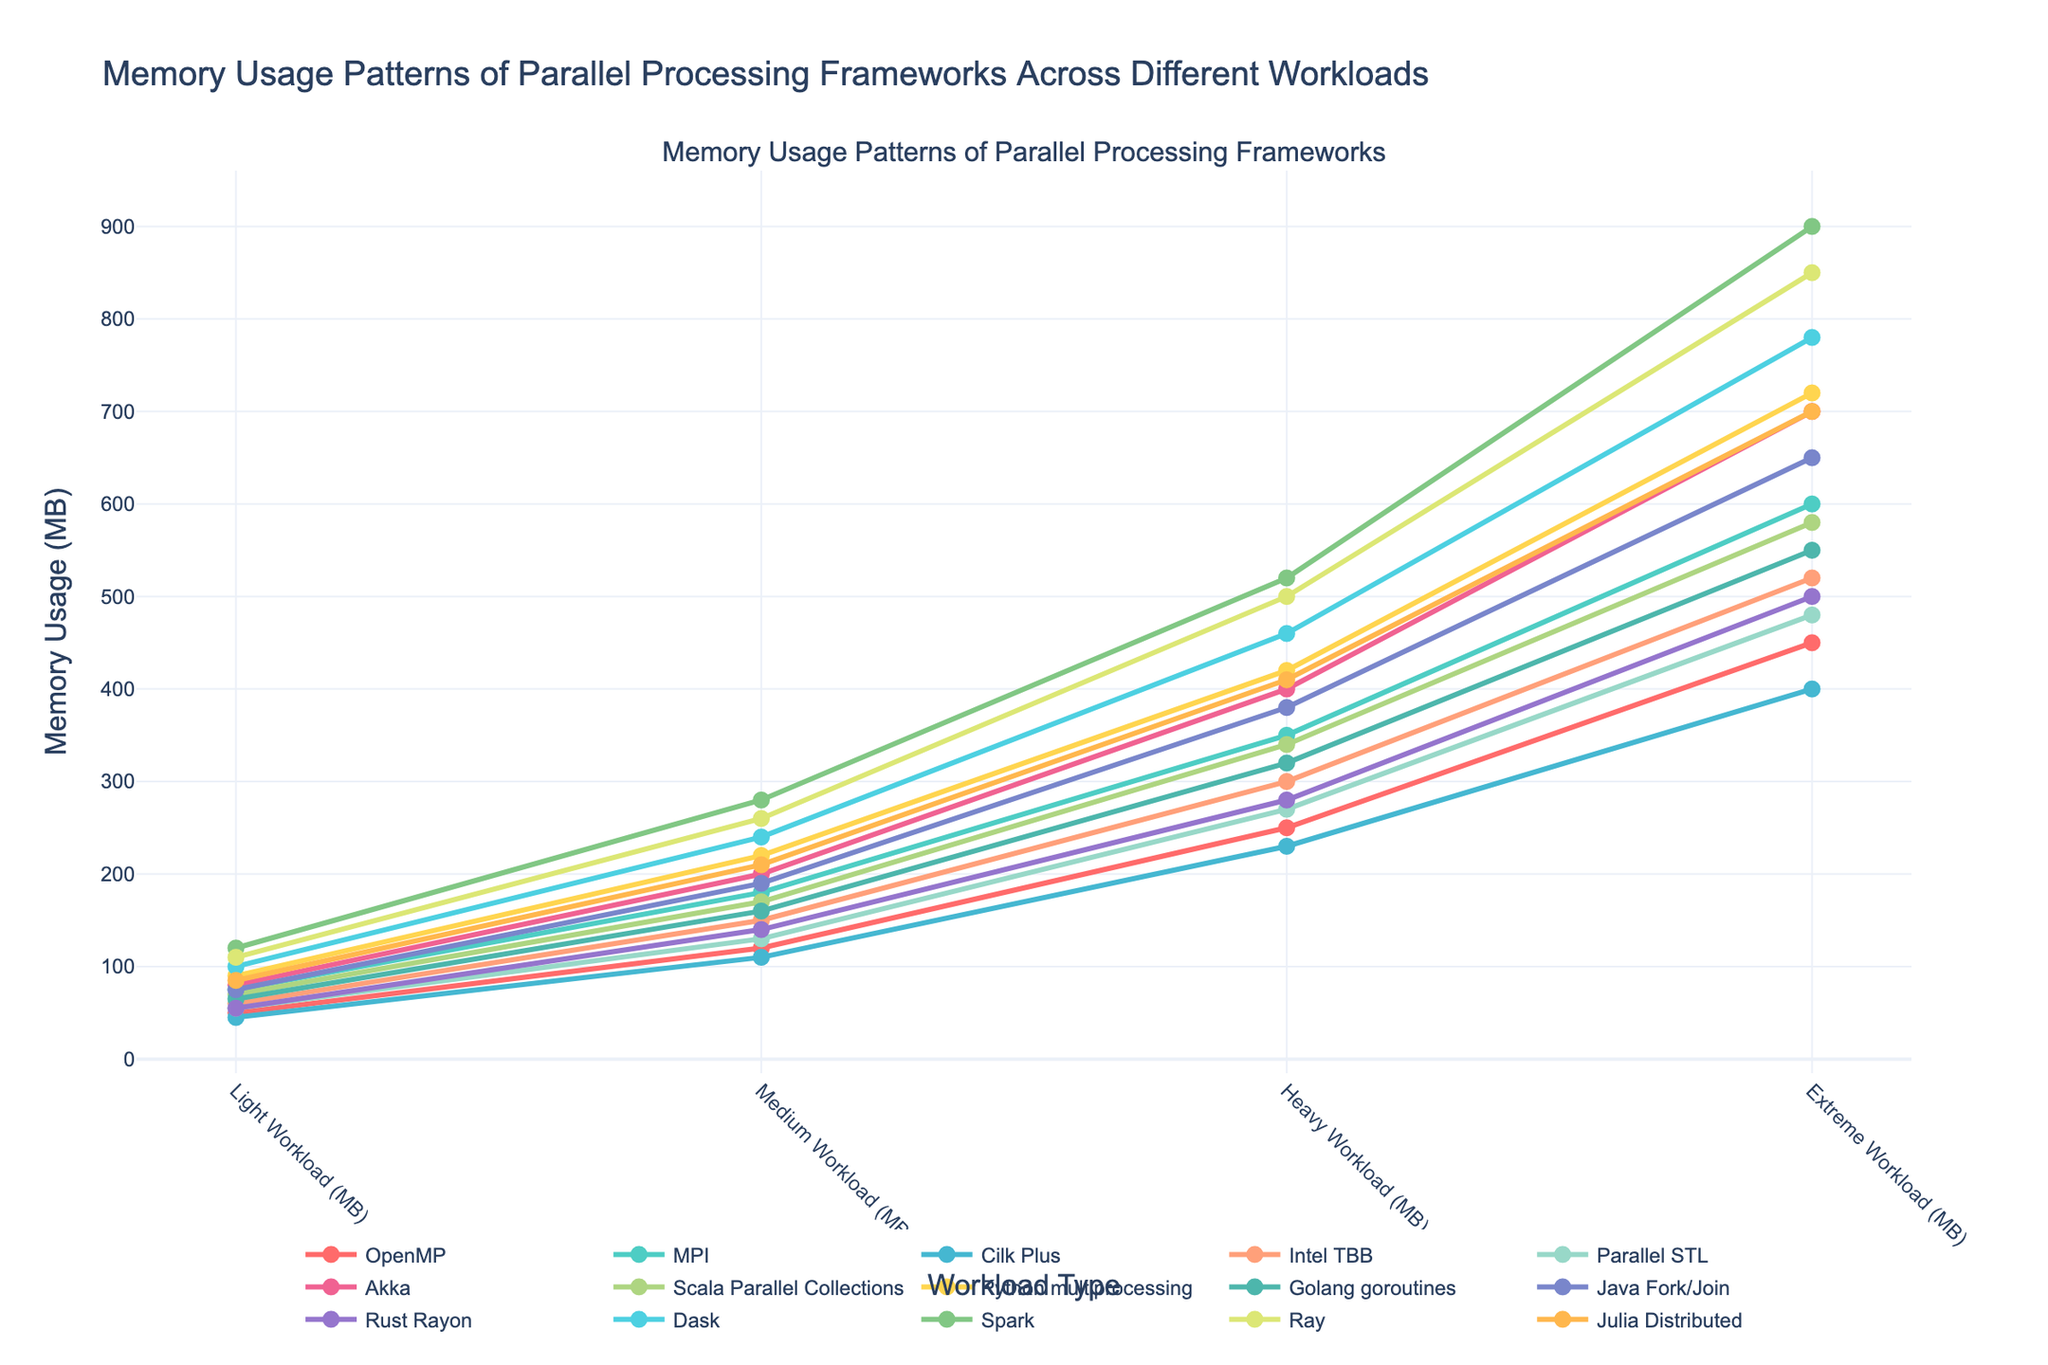Which framework has the highest memory usage for the Extreme Workload? To find the framework with the highest memory usage for the Extreme Workload, look at the data point corresponding to the Extreme Workload and identify the highest value. The highest value is 900 MB for Spark.
Answer: Spark Which frameworks have memory usage lower than 100 MB for the Light Workload? Identify the data points for the Light Workload and select values lower than 100 MB, which are OpenMP, Cilk Plus, Intel TBB, Parallel STL, Rust Rayon, and Golang goroutines.
Answer: OpenMP, Cilk Plus, Intel TBB, Parallel STL, Rust Rayon, Golang goroutines What is the total memory usage of Python multiprocessing across all workloads? Sum the memory usage values of Python multiprocessing across all four workloads: 90 + 220 + 420 + 720 = 1450 MB.
Answer: 1450 MB Compare the memory usage of Akka and Java Fork/Join for the Heavy Workload. Which one uses more memory? For the Heavy Workload, check the memory usage values for Akka (400 MB) and Java Fork/Join (380 MB). Akka uses more memory.
Answer: Akka What is the average memory usage of Rust Rayon for Medium and Heavy Workloads? Calculate the average by summing the memory usage of Rust Rayon for Medium (140 MB) and Heavy Workloads (280 MB) and then dividing by 2: (140 + 280) / 2 = 210 MB.
Answer: 210 MB How much more memory does Spark use compared to Ray under the Extreme Workload? Subtract Ray's memory usage under the Extreme Workload (850 MB) from Spark's (900 MB): 900 - 850 = 50 MB.
Answer: 50 MB Which framework shows the most significant increase in memory usage from the Light to the Medium Workload? Calculate the difference between Medium and Light Workloads for each framework and compare the differences. MPI has the highest increase of 105 MB (180 - 75 = 105).
Answer: MPI What is the difference between the highest and lowest memory usage values for the Extreme Workload? Identify the highest and lowest memory usage values for the Extreme Workload (900 MB for Spark and 450 MB for OpenMP) and subtract the lowest from the highest: 900 - 450 = 450 MB.
Answer: 450 MB Which framework has a consistent increase in memory usage across all workloads? For each framework, check if the memory usage value increases progressively from Light to Extreme. Intel TBB has memory usages of 60, 150, 300, and 520, showing a consistent increase.
Answer: Intel TBB Compare the memory usage of Golang goroutines and Scala Parallel Collections for the Medium Workload. Which one has lower memory usage and by how much? Check the memory usage values for Medium Workload (Golang goroutines - 160 MB and Scala Parallel Collections - 170 MB), then subtract Golang goroutines' memory usage from Scala (170 - 160 = 10 MB). Golang goroutines have lower memory usage by 10 MB.
Answer: Golang goroutines, 10 MB 